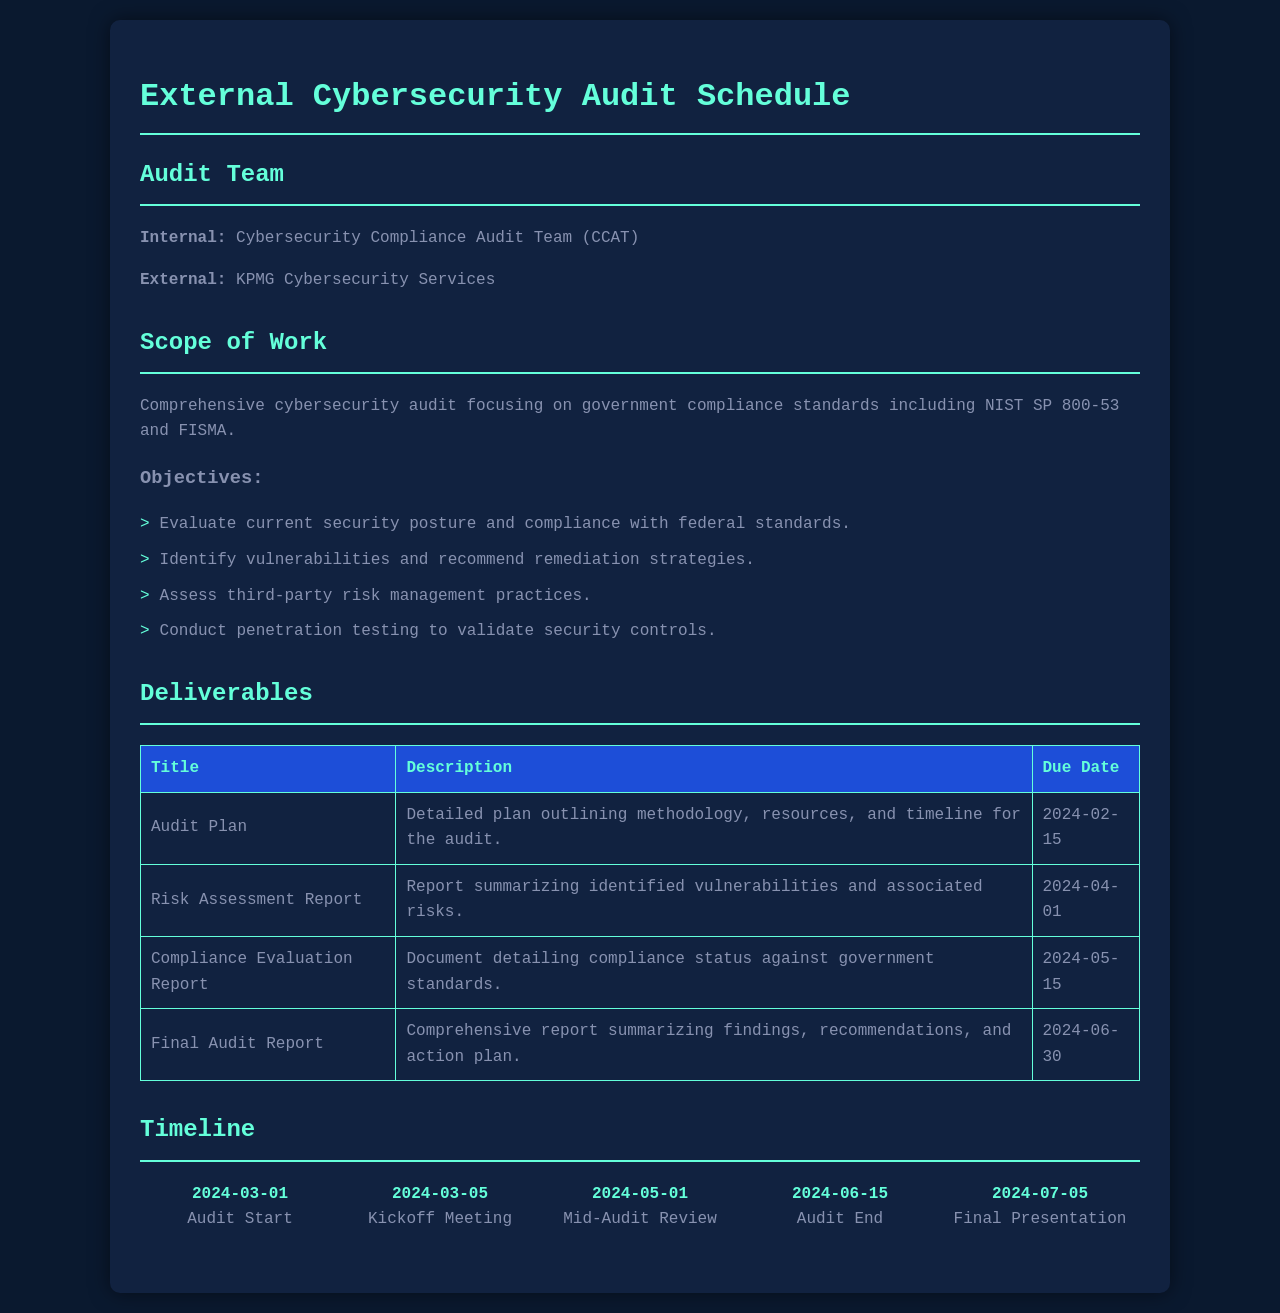What is the name of the internal audit team? The name of the internal audit team is specified in the document under the Audit Team section.
Answer: Cybersecurity Compliance Audit Team (CCAT) What is the due date for the Audit Plan? The due date for the Audit Plan is found in the Deliverables table under the Due Date column.
Answer: 2024-02-15 What is the primary focus of the cybersecurity audit? The primary focus is stated in the Scope of Work section, referring to the adherence to specific standards.
Answer: Government compliance standards How many deliverables are listed in the document? The number of deliverables can be counted from the Deliverables table, which includes all items listed there.
Answer: 4 When is the kickoff meeting scheduled? The kickoff meeting date is included in the timeline section of the document.
Answer: 2024-03-05 What type of testing will be conducted during the audit? The type of testing is covered in the Scope of Work objectives, which describes the testing conducted.
Answer: Penetration testing What document will summarize the findings and recommendations? The document that will summarize findings and recommendations is specified in the Deliverables table under the Title column.
Answer: Final Audit Report What date does the audit end? The ending date of the audit is found within the timeline section of the document.
Answer: 2024-06-15 Who is responsible for providing external cybersecurity services? The external service provider is mentioned in the Audit Team section of the document.
Answer: KPMG Cybersecurity Services 